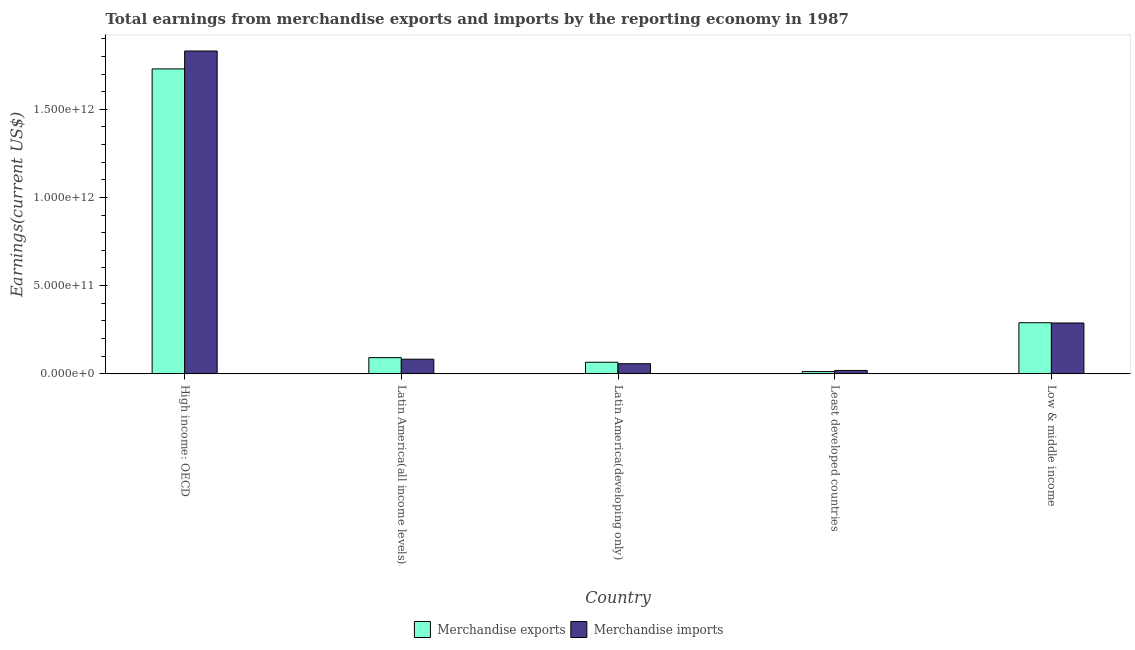How many groups of bars are there?
Keep it short and to the point. 5. How many bars are there on the 3rd tick from the left?
Your answer should be compact. 2. How many bars are there on the 1st tick from the right?
Make the answer very short. 2. What is the label of the 2nd group of bars from the left?
Ensure brevity in your answer.  Latin America(all income levels). In how many cases, is the number of bars for a given country not equal to the number of legend labels?
Ensure brevity in your answer.  0. What is the earnings from merchandise exports in High income: OECD?
Give a very brief answer. 1.73e+12. Across all countries, what is the maximum earnings from merchandise exports?
Your response must be concise. 1.73e+12. Across all countries, what is the minimum earnings from merchandise exports?
Make the answer very short. 1.22e+1. In which country was the earnings from merchandise exports maximum?
Offer a very short reply. High income: OECD. In which country was the earnings from merchandise imports minimum?
Keep it short and to the point. Least developed countries. What is the total earnings from merchandise imports in the graph?
Provide a short and direct response. 2.28e+12. What is the difference between the earnings from merchandise exports in Latin America(all income levels) and that in Latin America(developing only)?
Your response must be concise. 2.62e+1. What is the difference between the earnings from merchandise exports in High income: OECD and the earnings from merchandise imports in Low & middle income?
Keep it short and to the point. 1.44e+12. What is the average earnings from merchandise exports per country?
Ensure brevity in your answer.  4.37e+11. What is the difference between the earnings from merchandise imports and earnings from merchandise exports in Latin America(all income levels)?
Keep it short and to the point. -8.84e+09. What is the ratio of the earnings from merchandise imports in High income: OECD to that in Latin America(developing only)?
Offer a very short reply. 32.23. Is the earnings from merchandise exports in High income: OECD less than that in Latin America(all income levels)?
Your response must be concise. No. What is the difference between the highest and the second highest earnings from merchandise exports?
Make the answer very short. 1.44e+12. What is the difference between the highest and the lowest earnings from merchandise exports?
Your answer should be compact. 1.72e+12. In how many countries, is the earnings from merchandise exports greater than the average earnings from merchandise exports taken over all countries?
Keep it short and to the point. 1. What does the 2nd bar from the left in High income: OECD represents?
Offer a terse response. Merchandise imports. What does the 1st bar from the right in Least developed countries represents?
Make the answer very short. Merchandise imports. How many bars are there?
Your answer should be very brief. 10. Are all the bars in the graph horizontal?
Offer a terse response. No. How many countries are there in the graph?
Provide a succinct answer. 5. What is the difference between two consecutive major ticks on the Y-axis?
Your answer should be compact. 5.00e+11. Are the values on the major ticks of Y-axis written in scientific E-notation?
Your answer should be compact. Yes. Does the graph contain grids?
Make the answer very short. No. How many legend labels are there?
Provide a succinct answer. 2. How are the legend labels stacked?
Your response must be concise. Horizontal. What is the title of the graph?
Your response must be concise. Total earnings from merchandise exports and imports by the reporting economy in 1987. What is the label or title of the Y-axis?
Provide a succinct answer. Earnings(current US$). What is the Earnings(current US$) in Merchandise exports in High income: OECD?
Offer a terse response. 1.73e+12. What is the Earnings(current US$) of Merchandise imports in High income: OECD?
Offer a terse response. 1.83e+12. What is the Earnings(current US$) in Merchandise exports in Latin America(all income levels)?
Give a very brief answer. 9.14e+1. What is the Earnings(current US$) in Merchandise imports in Latin America(all income levels)?
Ensure brevity in your answer.  8.25e+1. What is the Earnings(current US$) of Merchandise exports in Latin America(developing only)?
Make the answer very short. 6.51e+1. What is the Earnings(current US$) in Merchandise imports in Latin America(developing only)?
Keep it short and to the point. 5.68e+1. What is the Earnings(current US$) of Merchandise exports in Least developed countries?
Keep it short and to the point. 1.22e+1. What is the Earnings(current US$) of Merchandise imports in Least developed countries?
Provide a short and direct response. 1.87e+1. What is the Earnings(current US$) in Merchandise exports in Low & middle income?
Give a very brief answer. 2.89e+11. What is the Earnings(current US$) in Merchandise imports in Low & middle income?
Offer a terse response. 2.88e+11. Across all countries, what is the maximum Earnings(current US$) of Merchandise exports?
Offer a very short reply. 1.73e+12. Across all countries, what is the maximum Earnings(current US$) of Merchandise imports?
Give a very brief answer. 1.83e+12. Across all countries, what is the minimum Earnings(current US$) of Merchandise exports?
Keep it short and to the point. 1.22e+1. Across all countries, what is the minimum Earnings(current US$) of Merchandise imports?
Make the answer very short. 1.87e+1. What is the total Earnings(current US$) of Merchandise exports in the graph?
Give a very brief answer. 2.19e+12. What is the total Earnings(current US$) in Merchandise imports in the graph?
Keep it short and to the point. 2.28e+12. What is the difference between the Earnings(current US$) of Merchandise exports in High income: OECD and that in Latin America(all income levels)?
Provide a succinct answer. 1.64e+12. What is the difference between the Earnings(current US$) of Merchandise imports in High income: OECD and that in Latin America(all income levels)?
Your answer should be compact. 1.75e+12. What is the difference between the Earnings(current US$) of Merchandise exports in High income: OECD and that in Latin America(developing only)?
Your answer should be very brief. 1.66e+12. What is the difference between the Earnings(current US$) of Merchandise imports in High income: OECD and that in Latin America(developing only)?
Provide a succinct answer. 1.77e+12. What is the difference between the Earnings(current US$) in Merchandise exports in High income: OECD and that in Least developed countries?
Offer a terse response. 1.72e+12. What is the difference between the Earnings(current US$) in Merchandise imports in High income: OECD and that in Least developed countries?
Give a very brief answer. 1.81e+12. What is the difference between the Earnings(current US$) in Merchandise exports in High income: OECD and that in Low & middle income?
Your response must be concise. 1.44e+12. What is the difference between the Earnings(current US$) of Merchandise imports in High income: OECD and that in Low & middle income?
Keep it short and to the point. 1.54e+12. What is the difference between the Earnings(current US$) of Merchandise exports in Latin America(all income levels) and that in Latin America(developing only)?
Ensure brevity in your answer.  2.62e+1. What is the difference between the Earnings(current US$) in Merchandise imports in Latin America(all income levels) and that in Latin America(developing only)?
Make the answer very short. 2.57e+1. What is the difference between the Earnings(current US$) in Merchandise exports in Latin America(all income levels) and that in Least developed countries?
Make the answer very short. 7.92e+1. What is the difference between the Earnings(current US$) of Merchandise imports in Latin America(all income levels) and that in Least developed countries?
Your answer should be very brief. 6.38e+1. What is the difference between the Earnings(current US$) in Merchandise exports in Latin America(all income levels) and that in Low & middle income?
Give a very brief answer. -1.98e+11. What is the difference between the Earnings(current US$) in Merchandise imports in Latin America(all income levels) and that in Low & middle income?
Ensure brevity in your answer.  -2.05e+11. What is the difference between the Earnings(current US$) in Merchandise exports in Latin America(developing only) and that in Least developed countries?
Ensure brevity in your answer.  5.30e+1. What is the difference between the Earnings(current US$) in Merchandise imports in Latin America(developing only) and that in Least developed countries?
Provide a short and direct response. 3.81e+1. What is the difference between the Earnings(current US$) of Merchandise exports in Latin America(developing only) and that in Low & middle income?
Ensure brevity in your answer.  -2.24e+11. What is the difference between the Earnings(current US$) of Merchandise imports in Latin America(developing only) and that in Low & middle income?
Your answer should be very brief. -2.31e+11. What is the difference between the Earnings(current US$) of Merchandise exports in Least developed countries and that in Low & middle income?
Ensure brevity in your answer.  -2.77e+11. What is the difference between the Earnings(current US$) in Merchandise imports in Least developed countries and that in Low & middle income?
Offer a very short reply. -2.69e+11. What is the difference between the Earnings(current US$) in Merchandise exports in High income: OECD and the Earnings(current US$) in Merchandise imports in Latin America(all income levels)?
Your answer should be compact. 1.65e+12. What is the difference between the Earnings(current US$) in Merchandise exports in High income: OECD and the Earnings(current US$) in Merchandise imports in Latin America(developing only)?
Provide a succinct answer. 1.67e+12. What is the difference between the Earnings(current US$) in Merchandise exports in High income: OECD and the Earnings(current US$) in Merchandise imports in Least developed countries?
Your response must be concise. 1.71e+12. What is the difference between the Earnings(current US$) of Merchandise exports in High income: OECD and the Earnings(current US$) of Merchandise imports in Low & middle income?
Ensure brevity in your answer.  1.44e+12. What is the difference between the Earnings(current US$) in Merchandise exports in Latin America(all income levels) and the Earnings(current US$) in Merchandise imports in Latin America(developing only)?
Your answer should be compact. 3.45e+1. What is the difference between the Earnings(current US$) in Merchandise exports in Latin America(all income levels) and the Earnings(current US$) in Merchandise imports in Least developed countries?
Give a very brief answer. 7.27e+1. What is the difference between the Earnings(current US$) of Merchandise exports in Latin America(all income levels) and the Earnings(current US$) of Merchandise imports in Low & middle income?
Offer a terse response. -1.97e+11. What is the difference between the Earnings(current US$) in Merchandise exports in Latin America(developing only) and the Earnings(current US$) in Merchandise imports in Least developed countries?
Provide a succinct answer. 4.64e+1. What is the difference between the Earnings(current US$) of Merchandise exports in Latin America(developing only) and the Earnings(current US$) of Merchandise imports in Low & middle income?
Provide a short and direct response. -2.23e+11. What is the difference between the Earnings(current US$) in Merchandise exports in Least developed countries and the Earnings(current US$) in Merchandise imports in Low & middle income?
Provide a succinct answer. -2.76e+11. What is the average Earnings(current US$) in Merchandise exports per country?
Offer a very short reply. 4.37e+11. What is the average Earnings(current US$) in Merchandise imports per country?
Your response must be concise. 4.55e+11. What is the difference between the Earnings(current US$) in Merchandise exports and Earnings(current US$) in Merchandise imports in High income: OECD?
Your answer should be compact. -1.02e+11. What is the difference between the Earnings(current US$) in Merchandise exports and Earnings(current US$) in Merchandise imports in Latin America(all income levels)?
Give a very brief answer. 8.84e+09. What is the difference between the Earnings(current US$) in Merchandise exports and Earnings(current US$) in Merchandise imports in Latin America(developing only)?
Provide a short and direct response. 8.34e+09. What is the difference between the Earnings(current US$) of Merchandise exports and Earnings(current US$) of Merchandise imports in Least developed countries?
Ensure brevity in your answer.  -6.52e+09. What is the difference between the Earnings(current US$) in Merchandise exports and Earnings(current US$) in Merchandise imports in Low & middle income?
Offer a very short reply. 1.50e+09. What is the ratio of the Earnings(current US$) of Merchandise exports in High income: OECD to that in Latin America(all income levels)?
Offer a terse response. 18.93. What is the ratio of the Earnings(current US$) in Merchandise imports in High income: OECD to that in Latin America(all income levels)?
Provide a short and direct response. 22.19. What is the ratio of the Earnings(current US$) in Merchandise exports in High income: OECD to that in Latin America(developing only)?
Provide a short and direct response. 26.55. What is the ratio of the Earnings(current US$) of Merchandise imports in High income: OECD to that in Latin America(developing only)?
Provide a short and direct response. 32.23. What is the ratio of the Earnings(current US$) of Merchandise exports in High income: OECD to that in Least developed countries?
Your answer should be very brief. 141.98. What is the ratio of the Earnings(current US$) in Merchandise imports in High income: OECD to that in Least developed countries?
Give a very brief answer. 97.9. What is the ratio of the Earnings(current US$) in Merchandise exports in High income: OECD to that in Low & middle income?
Your answer should be very brief. 5.98. What is the ratio of the Earnings(current US$) of Merchandise imports in High income: OECD to that in Low & middle income?
Offer a terse response. 6.36. What is the ratio of the Earnings(current US$) of Merchandise exports in Latin America(all income levels) to that in Latin America(developing only)?
Give a very brief answer. 1.4. What is the ratio of the Earnings(current US$) of Merchandise imports in Latin America(all income levels) to that in Latin America(developing only)?
Your answer should be very brief. 1.45. What is the ratio of the Earnings(current US$) of Merchandise exports in Latin America(all income levels) to that in Least developed countries?
Your answer should be compact. 7.5. What is the ratio of the Earnings(current US$) of Merchandise imports in Latin America(all income levels) to that in Least developed countries?
Offer a very short reply. 4.41. What is the ratio of the Earnings(current US$) in Merchandise exports in Latin America(all income levels) to that in Low & middle income?
Your answer should be very brief. 0.32. What is the ratio of the Earnings(current US$) of Merchandise imports in Latin America(all income levels) to that in Low & middle income?
Make the answer very short. 0.29. What is the ratio of the Earnings(current US$) in Merchandise exports in Latin America(developing only) to that in Least developed countries?
Your answer should be compact. 5.35. What is the ratio of the Earnings(current US$) of Merchandise imports in Latin America(developing only) to that in Least developed countries?
Offer a terse response. 3.04. What is the ratio of the Earnings(current US$) in Merchandise exports in Latin America(developing only) to that in Low & middle income?
Offer a terse response. 0.23. What is the ratio of the Earnings(current US$) of Merchandise imports in Latin America(developing only) to that in Low & middle income?
Your answer should be very brief. 0.2. What is the ratio of the Earnings(current US$) in Merchandise exports in Least developed countries to that in Low & middle income?
Your answer should be very brief. 0.04. What is the ratio of the Earnings(current US$) in Merchandise imports in Least developed countries to that in Low & middle income?
Keep it short and to the point. 0.07. What is the difference between the highest and the second highest Earnings(current US$) of Merchandise exports?
Provide a succinct answer. 1.44e+12. What is the difference between the highest and the second highest Earnings(current US$) of Merchandise imports?
Give a very brief answer. 1.54e+12. What is the difference between the highest and the lowest Earnings(current US$) of Merchandise exports?
Offer a terse response. 1.72e+12. What is the difference between the highest and the lowest Earnings(current US$) in Merchandise imports?
Your answer should be compact. 1.81e+12. 